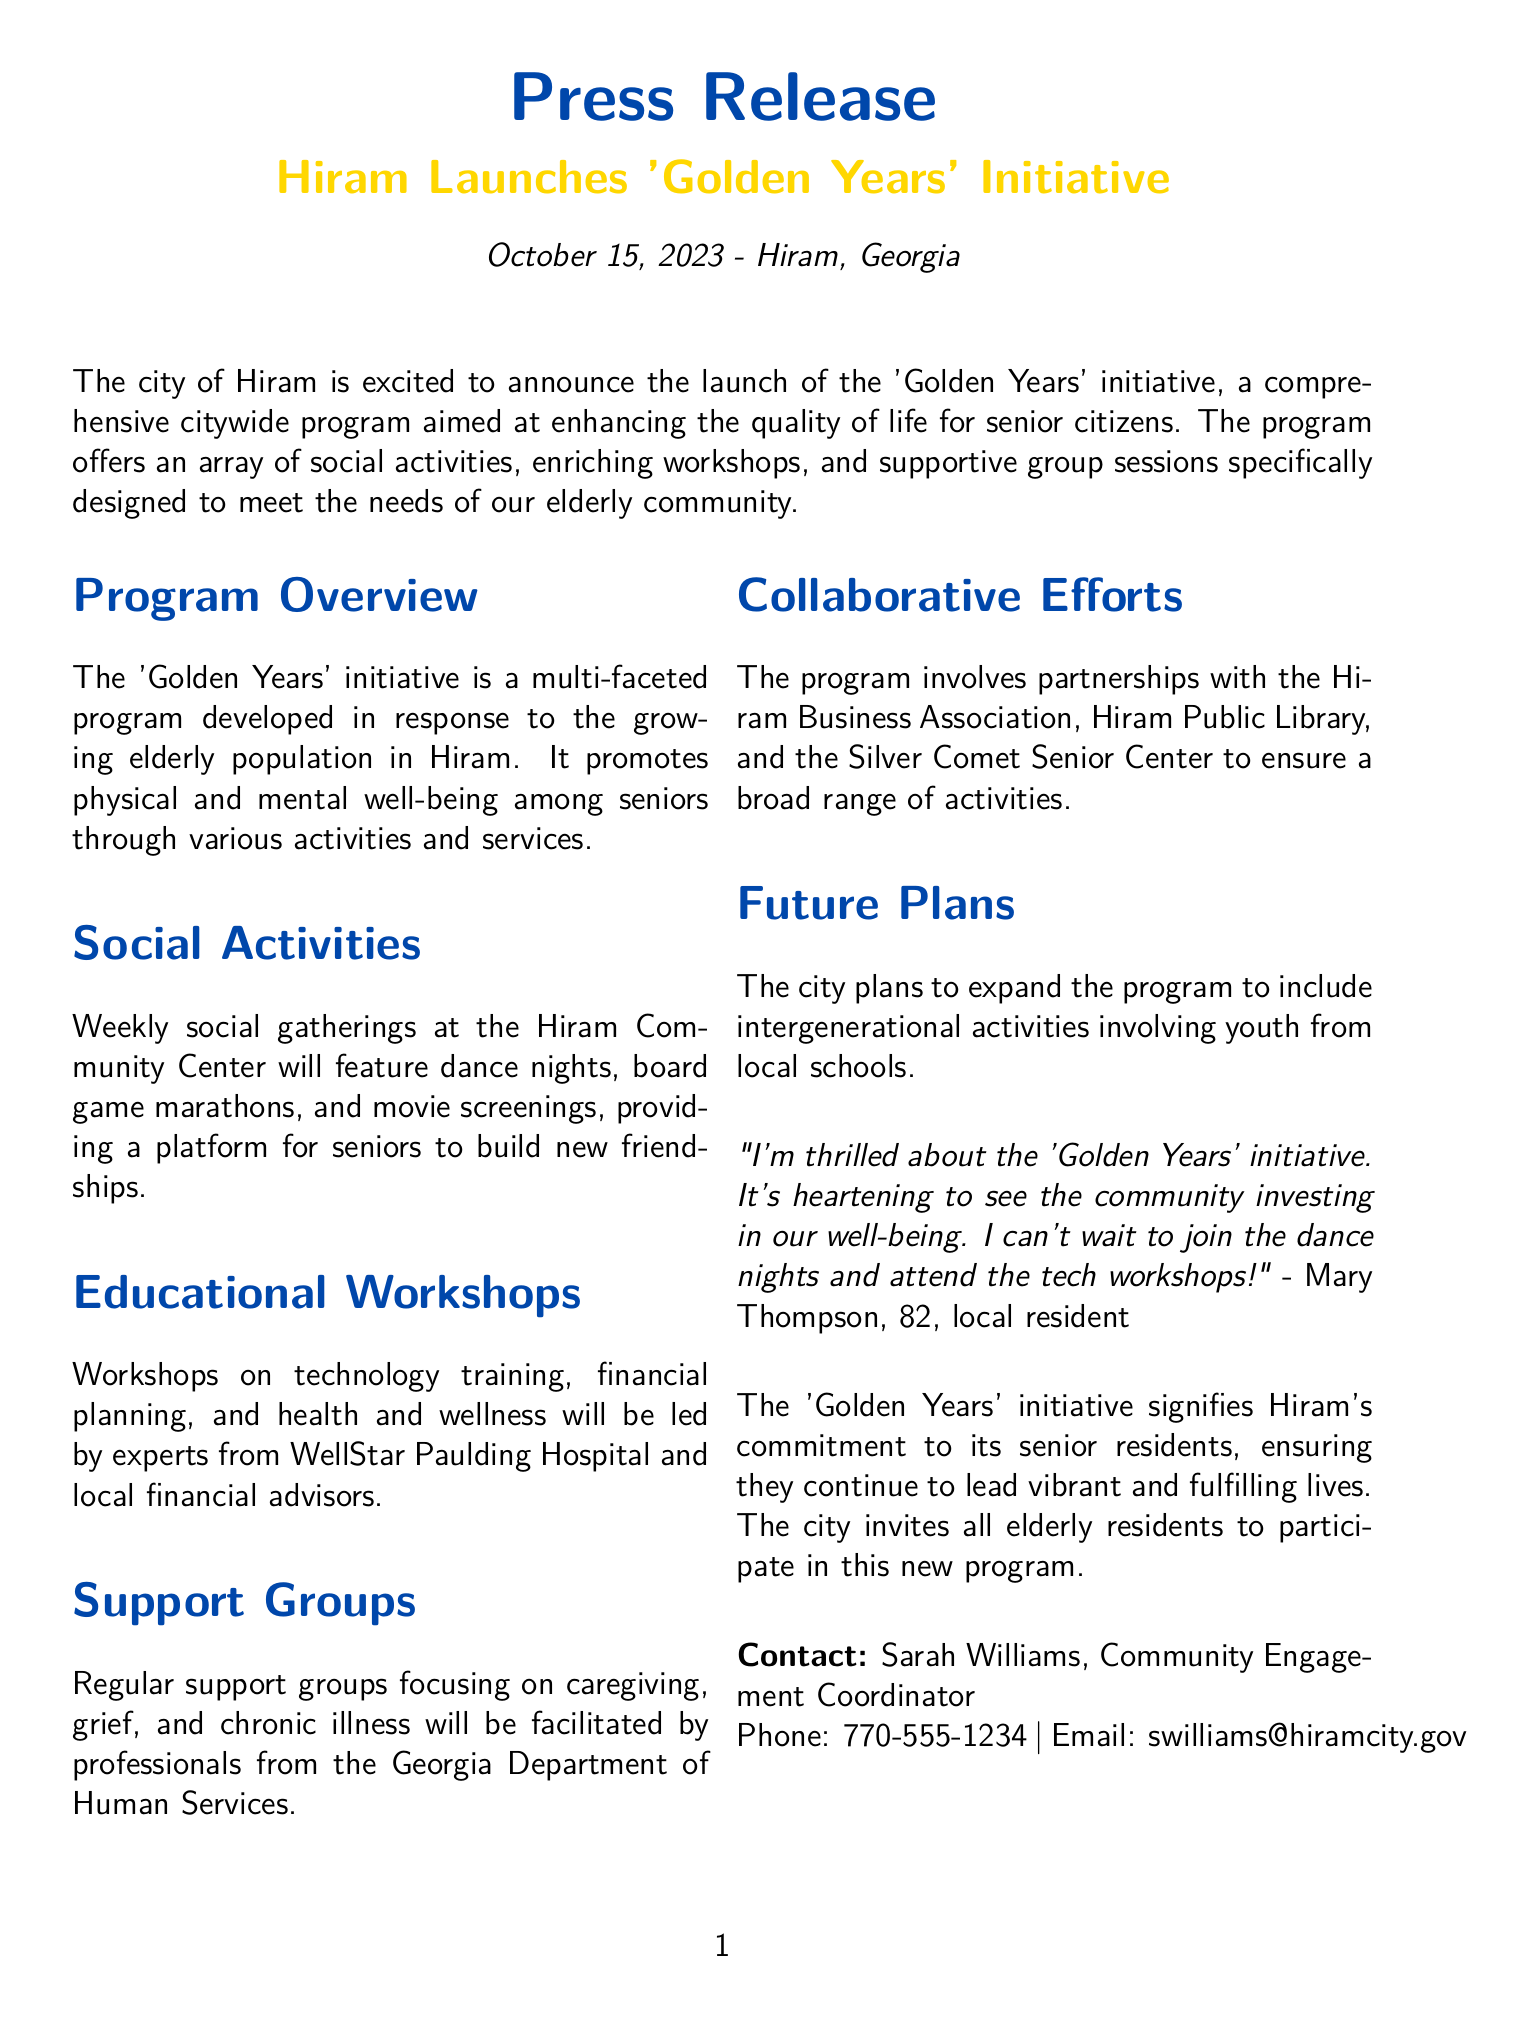What is the name of the initiative? The name of the initiative is clearly stated at the beginning of the document as 'Golden Years'.
Answer: 'Golden Years' What date was the initiative announced? The announcement date is given in the document as October 15, 2023.
Answer: October 15, 2023 Where will the weekly social gatherings be held? The location for the gatherings is specified as the Hiram Community Center.
Answer: Hiram Community Center Who is the contact person for the initiative? The contact person is mentioned as Sarah Williams in the closing section of the document.
Answer: Sarah Williams What type of workshops will be included in the program? The document details that workshops on technology training, financial planning, and health and wellness will be included.
Answer: technology training, financial planning, health and wellness How does the program plan to involve local youth in the future? The future plan includes incorporating intergenerational activities involving youth from local schools.
Answer: intergenerational activities Which organization is involved in facilitating support groups? The document specifies that the Georgia Department of Human Services is involved in facilitating support groups.
Answer: Georgia Department of Human Services What type of events will be featured on dance nights? The events that will take place on dance nights include social dancing as part of the gatherings.
Answer: dance nights 